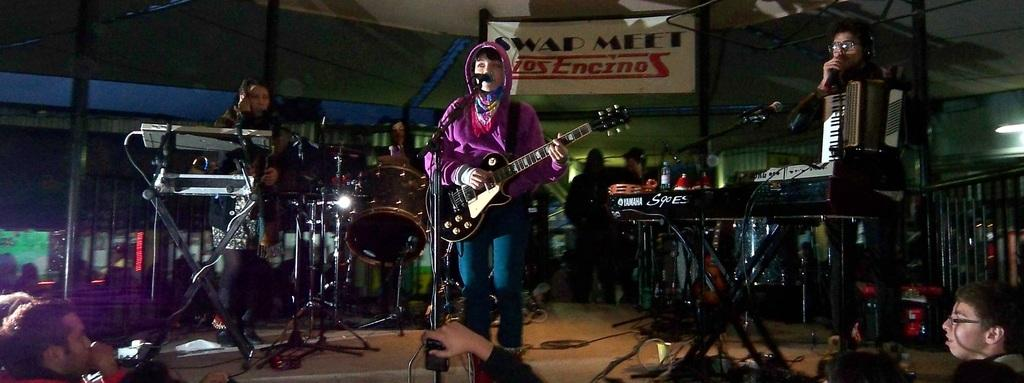What are the people in the image doing? The people in the image are playing musical instruments on a stage. What can be seen at the top of the image? There is some text at the top of the image. Are there any people visible at the bottom of the image? Yes, there are people at the bottom of the image. What type of noise can be heard coming from the cat in the image? There is no cat present in the image, so it is not possible to determine what noise, if any, might be coming from a cat. 